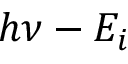Convert formula to latex. <formula><loc_0><loc_0><loc_500><loc_500>h \nu - E _ { i }</formula> 